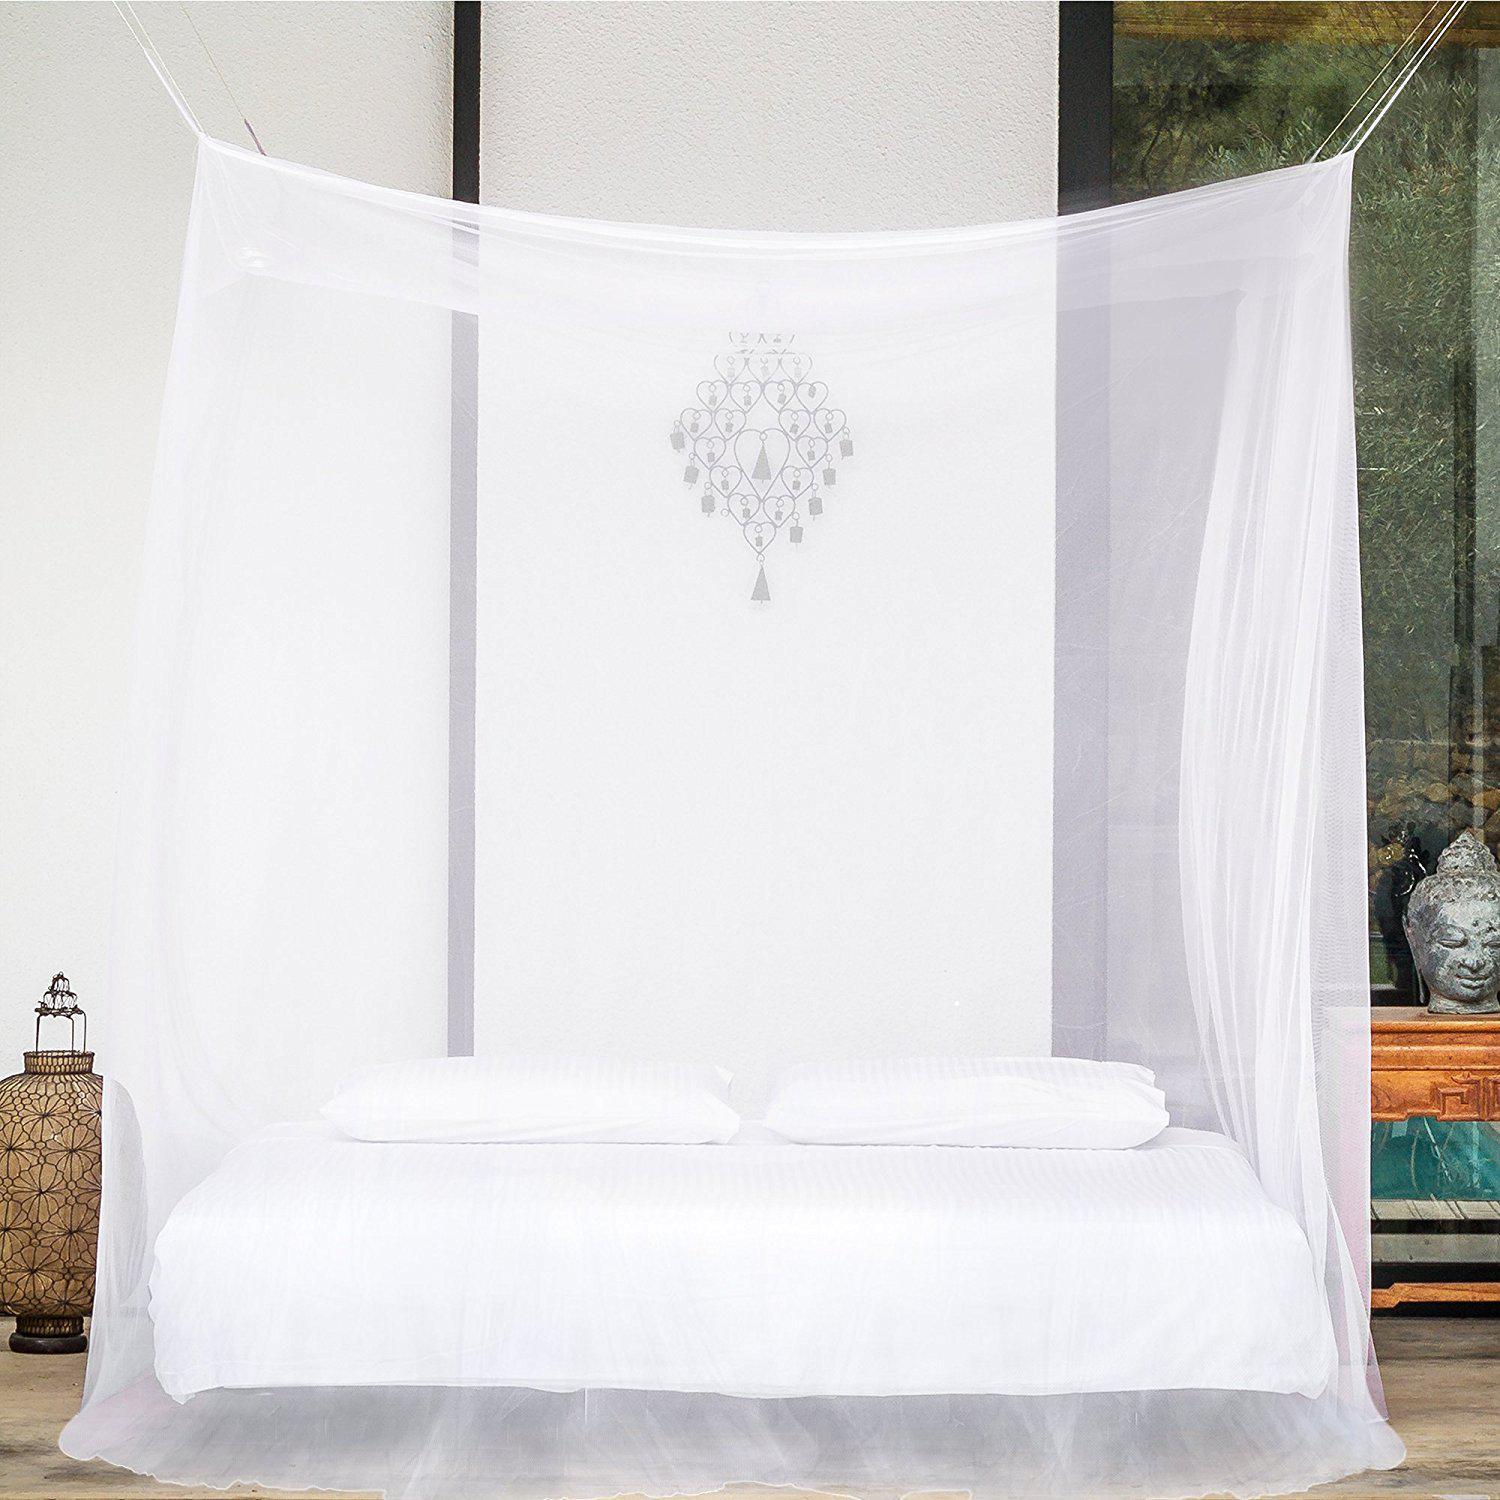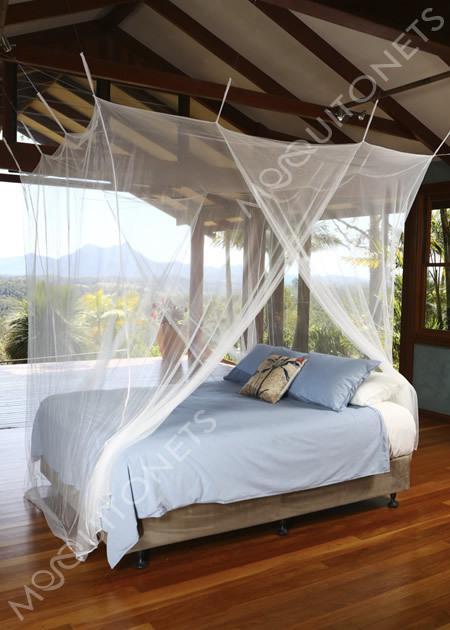The first image is the image on the left, the second image is the image on the right. Evaluate the accuracy of this statement regarding the images: "All bed nets are hanging from a central hook above the bed and draped outward.". Is it true? Answer yes or no. No. The first image is the image on the left, the second image is the image on the right. Considering the images on both sides, is "All images show a bed covered by a cone-shaped canopy." valid? Answer yes or no. No. 